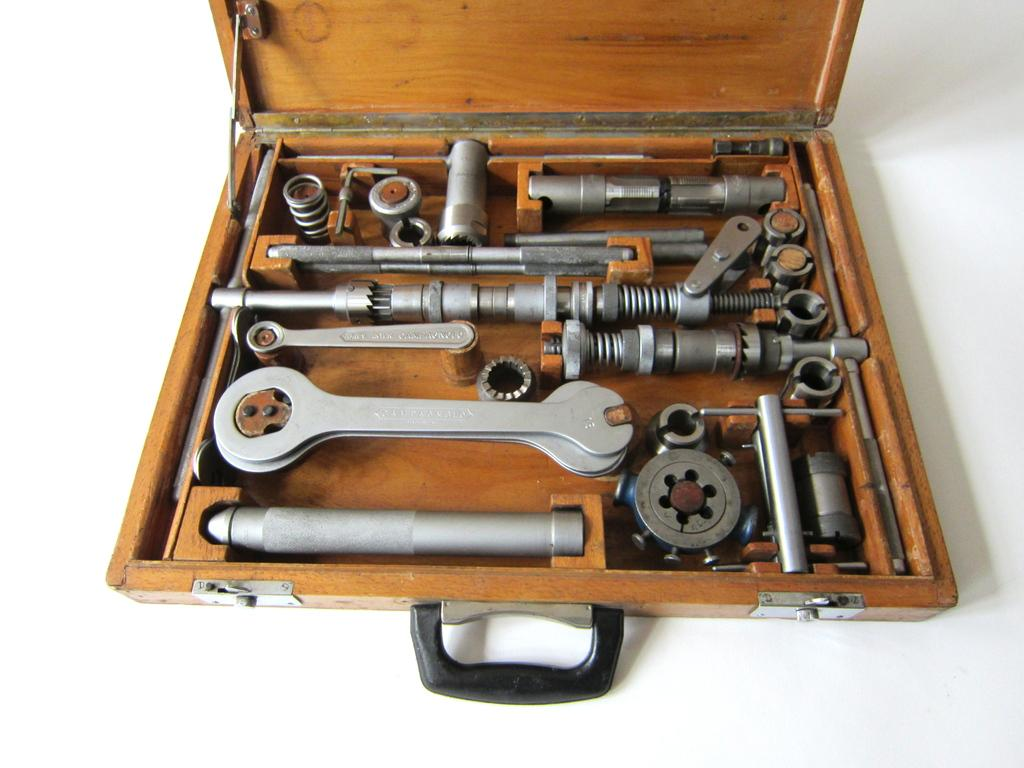What is the primary color of the surface in the image? The primary color of the surface in the image is white. What object is placed on the white surface? There is a wooden box on the white surface. What is inside the wooden box? The wooden box contains tools. How many snails can be seen crawling on the wooden box in the image? There are no snails present in the image; it features a white surface with a wooden box containing tools. What type of flowers are growing on the white surface in the image? There are no flowers present on the white surface in the image; it only features a wooden box containing tools. 